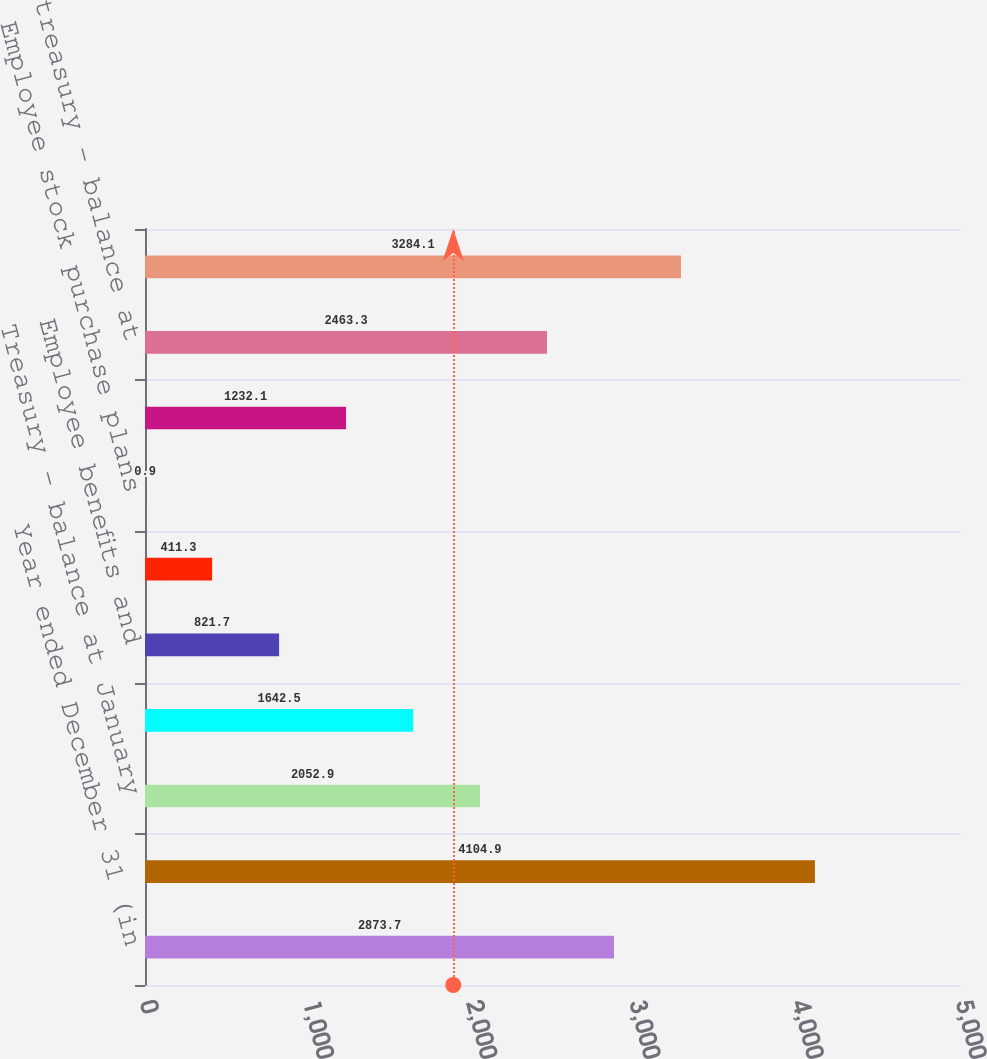Convert chart. <chart><loc_0><loc_0><loc_500><loc_500><bar_chart><fcel>Year ended December 31 (in<fcel>Total issued - balance at<fcel>Treasury - balance at January<fcel>Repurchase<fcel>Employee benefits and<fcel>Warrant exercise<fcel>Employee stock purchase plans<fcel>Total reissuance<fcel>Total treasury - balance at<fcel>Outstanding at December 31<nl><fcel>2873.7<fcel>4104.9<fcel>2052.9<fcel>1642.5<fcel>821.7<fcel>411.3<fcel>0.9<fcel>1232.1<fcel>2463.3<fcel>3284.1<nl></chart> 